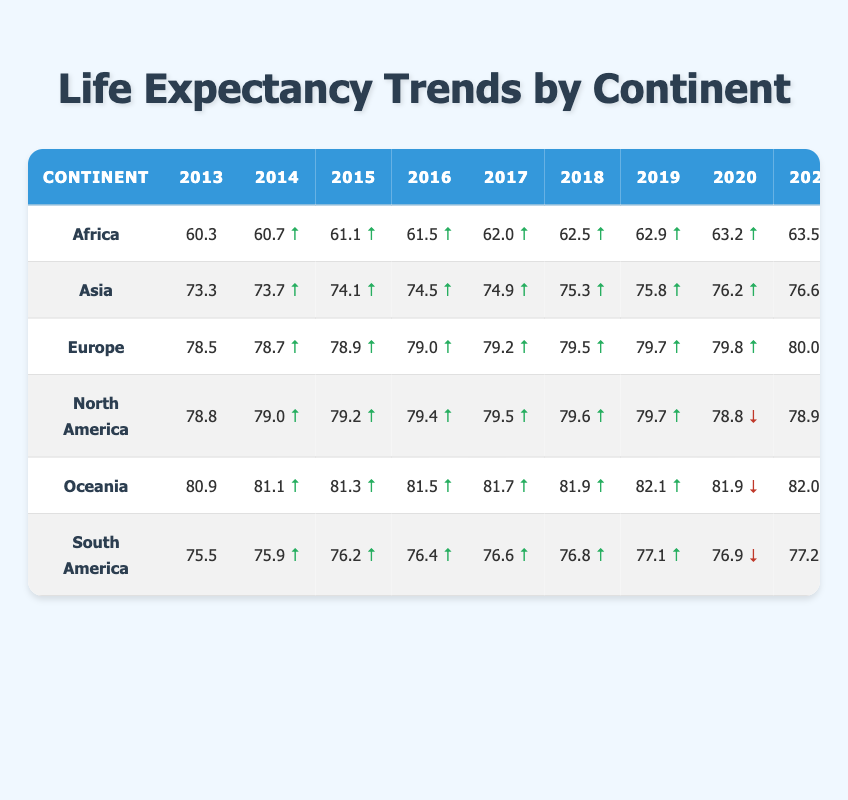What was the life expectancy in Africa in 2022? According to the table, the life expectancy in Africa for the year 2022 is listed directly under that column, which shows 63.8 years.
Answer: 63.8 Which continent had the highest life expectancy in 2013? By looking across the values in the year 2013, Europe has the highest life expectancy at 78.5 years.
Answer: Europe What is the difference in life expectancy between Asia in 2013 and in 2022? The life expectancy in Asia in 2013 is 73.3 years and in 2022 it is 77.0 years. The difference is 77.0 - 73.3 = 3.7 years.
Answer: 3.7 Did any continent experience a decline in life expectancy from 2019 to 2020? Checking the values from the table, North America declined from 79.7 in 2019 to 78.8 in 2020, confirming a decline.
Answer: Yes What is the average life expectancy in South America over these years? There are ten data points from 2013 to 2022: 75.5, 75.9, 76.2, 76.4, 76.6, 76.8, 77.1, 76.9, 77.2, 77.5. The sum of these values is 767.7, and to find the average, we divide by 10: 767.7 / 10 = 76.77 years.
Answer: 76.77 Which continent had the smallest increase in life expectancy during the decade? By evaluating the year 2013 and year 2022 life expectancies: Africa increased from 60.3 to 63.8 (3.5 years), Asia increased from 73.3 to 77.0 (3.7 years), and so forth, we find North America had a minimal increase, starting at 78.8 and ending in 79.1 (0.3 years).
Answer: North America Identify which continent had the lowest life expectancy in 2019. The table shows that the life expectancy in Africa for 2019 is 62.9 years, being lower than any other continent listed for that year.
Answer: Africa What was the trend in life expectancy for Oceania from 2020 to 2022? In 2020, Oceania had a life expectancy of 81.9 years, which increased to 82.0 in 2021, and then to 82.3 in 2022, indicating a consistent upward trend across these years.
Answer: Upward trend 